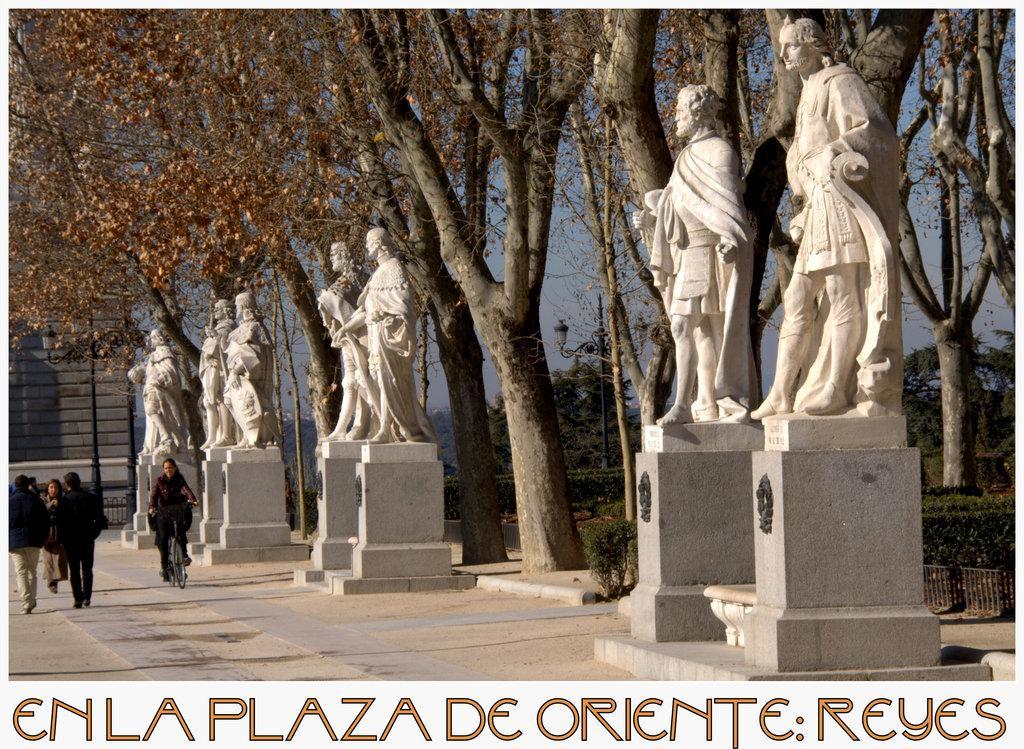Please provide a concise description of this image. In this image there are a few people walking on the path, beside them there is a person riding a bicycle, beside them there are a few depictions of the persons on the rock structure, behind them there are trees and plants. In the background there is a building and the sky, at the bottom of the image there is some text. 